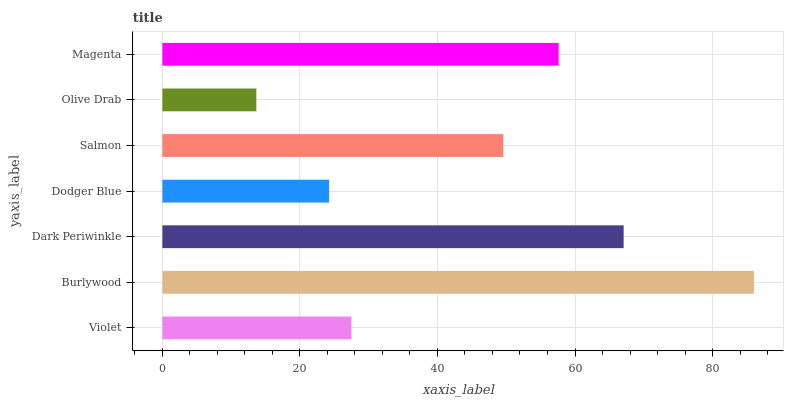Is Olive Drab the minimum?
Answer yes or no. Yes. Is Burlywood the maximum?
Answer yes or no. Yes. Is Dark Periwinkle the minimum?
Answer yes or no. No. Is Dark Periwinkle the maximum?
Answer yes or no. No. Is Burlywood greater than Dark Periwinkle?
Answer yes or no. Yes. Is Dark Periwinkle less than Burlywood?
Answer yes or no. Yes. Is Dark Periwinkle greater than Burlywood?
Answer yes or no. No. Is Burlywood less than Dark Periwinkle?
Answer yes or no. No. Is Salmon the high median?
Answer yes or no. Yes. Is Salmon the low median?
Answer yes or no. Yes. Is Violet the high median?
Answer yes or no. No. Is Dark Periwinkle the low median?
Answer yes or no. No. 